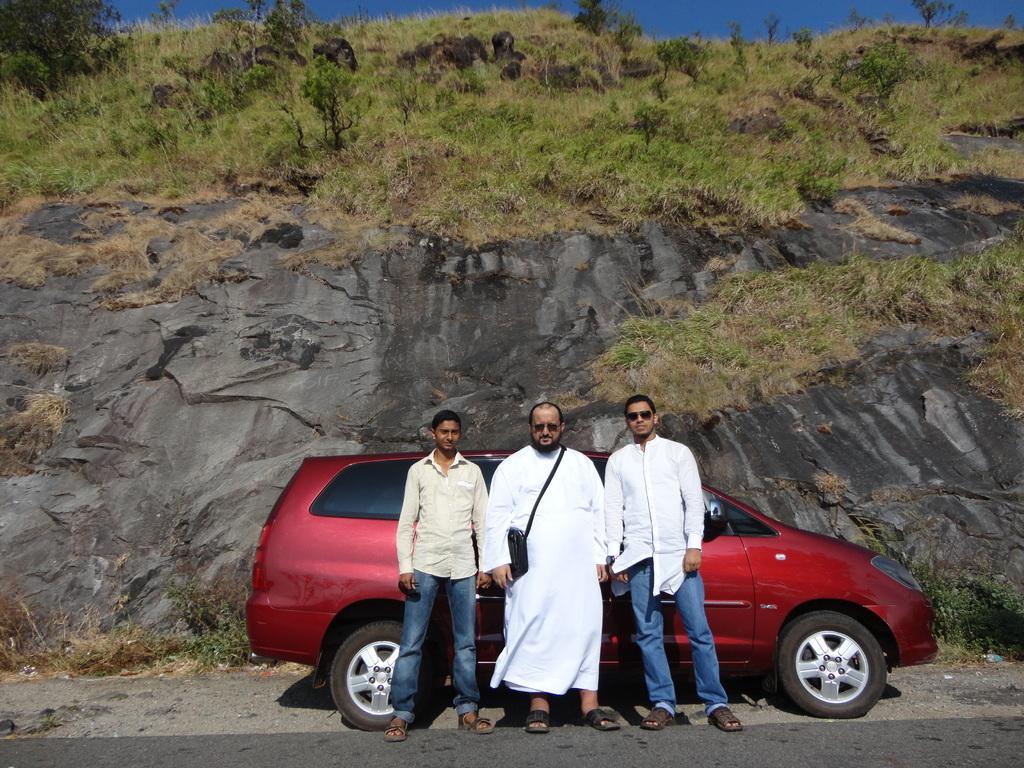Can you describe this image briefly? In this image I can see three people standing in-front of car on the road, behind them there is a mountain on which we can see some plants and grass. 